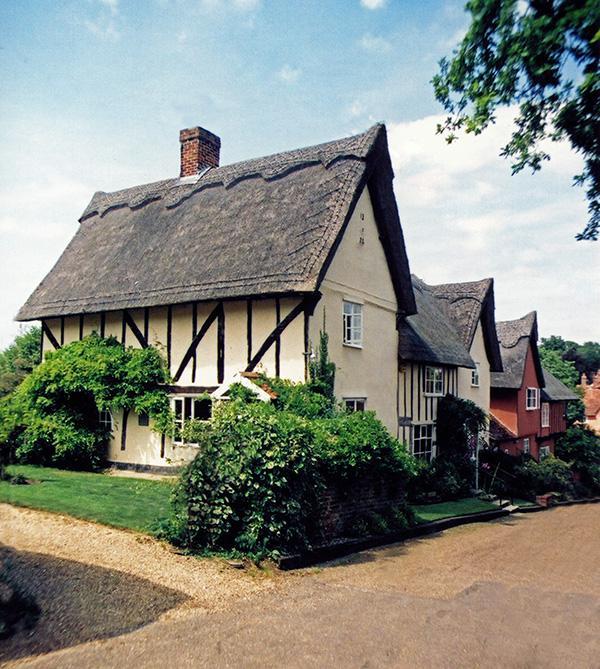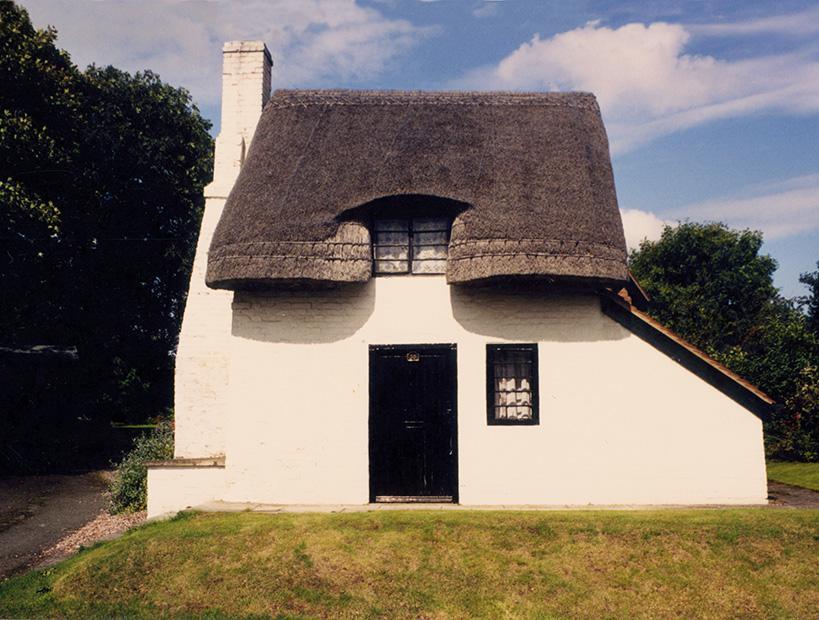The first image is the image on the left, the second image is the image on the right. Examine the images to the left and right. Is the description "The left image shows the front of a white house with bold dark lines on it forming geometric patterns, a chimney on the left end, and a thick gray peaked roof with at least one notched cut-out for windows." accurate? Answer yes or no. No. The first image is the image on the left, the second image is the image on the right. Assess this claim about the two images: "There is a fence bordering the house in one of the images.". Correct or not? Answer yes or no. No. 